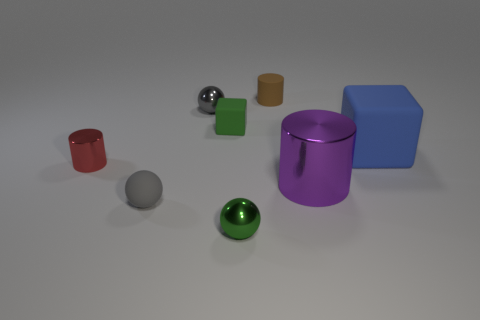Add 2 red cylinders. How many objects exist? 10 Subtract all blocks. How many objects are left? 6 Add 5 tiny green rubber objects. How many tiny green rubber objects are left? 6 Add 5 large red matte spheres. How many large red matte spheres exist? 5 Subtract 0 red blocks. How many objects are left? 8 Subtract all big brown shiny cylinders. Subtract all purple metal objects. How many objects are left? 7 